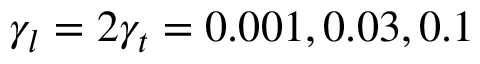<formula> <loc_0><loc_0><loc_500><loc_500>\gamma _ { l } = 2 \gamma _ { t } = 0 . 0 0 1 , 0 . 0 3 , 0 . 1</formula> 